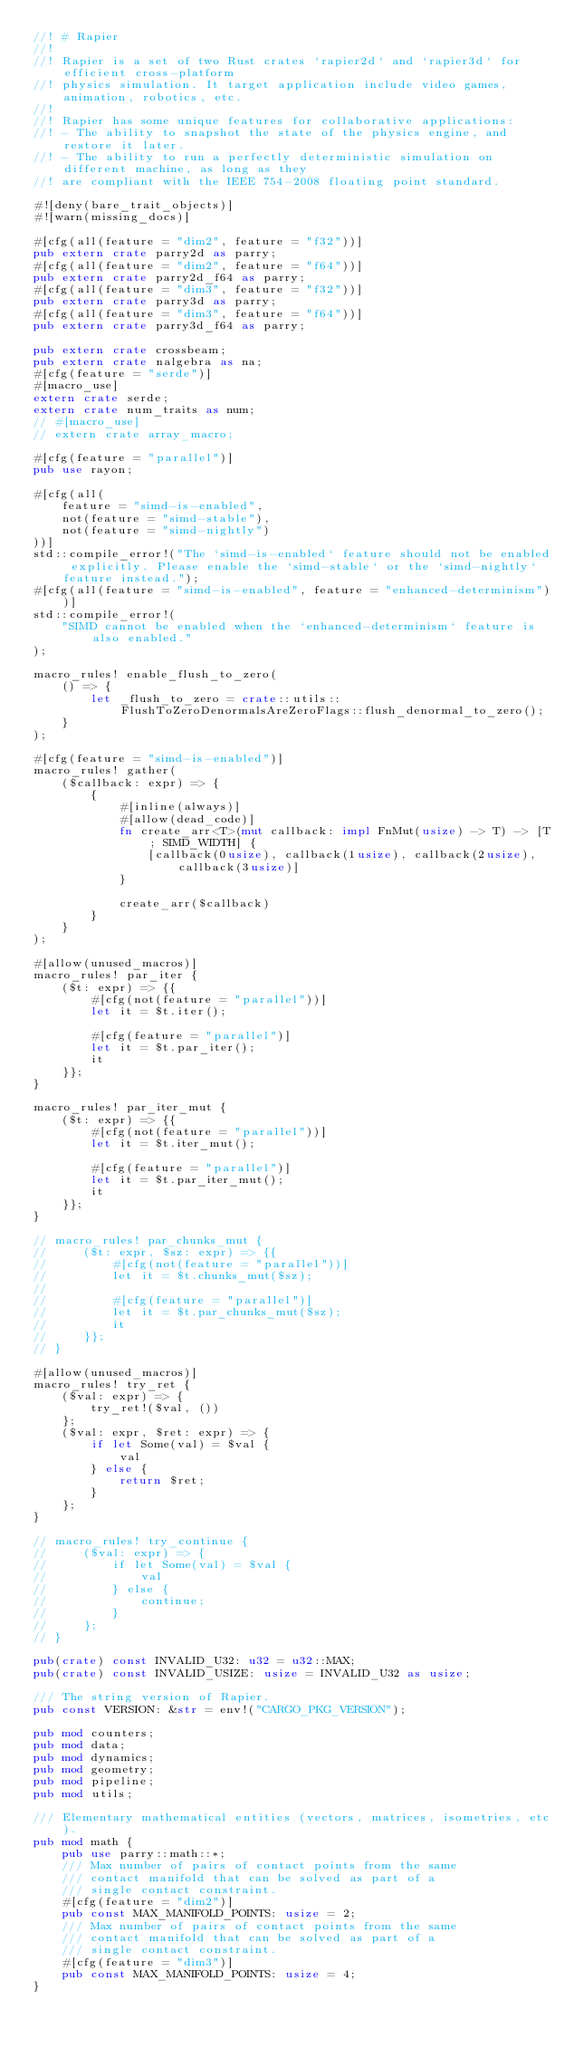<code> <loc_0><loc_0><loc_500><loc_500><_Rust_>//! # Rapier
//!
//! Rapier is a set of two Rust crates `rapier2d` and `rapier3d` for efficient cross-platform
//! physics simulation. It target application include video games, animation, robotics, etc.
//!
//! Rapier has some unique features for collaborative applications:
//! - The ability to snapshot the state of the physics engine, and restore it later.
//! - The ability to run a perfectly deterministic simulation on different machine, as long as they
//! are compliant with the IEEE 754-2008 floating point standard.

#![deny(bare_trait_objects)]
#![warn(missing_docs)]

#[cfg(all(feature = "dim2", feature = "f32"))]
pub extern crate parry2d as parry;
#[cfg(all(feature = "dim2", feature = "f64"))]
pub extern crate parry2d_f64 as parry;
#[cfg(all(feature = "dim3", feature = "f32"))]
pub extern crate parry3d as parry;
#[cfg(all(feature = "dim3", feature = "f64"))]
pub extern crate parry3d_f64 as parry;

pub extern crate crossbeam;
pub extern crate nalgebra as na;
#[cfg(feature = "serde")]
#[macro_use]
extern crate serde;
extern crate num_traits as num;
// #[macro_use]
// extern crate array_macro;

#[cfg(feature = "parallel")]
pub use rayon;

#[cfg(all(
    feature = "simd-is-enabled",
    not(feature = "simd-stable"),
    not(feature = "simd-nightly")
))]
std::compile_error!("The `simd-is-enabled` feature should not be enabled explicitly. Please enable the `simd-stable` or the `simd-nightly` feature instead.");
#[cfg(all(feature = "simd-is-enabled", feature = "enhanced-determinism"))]
std::compile_error!(
    "SIMD cannot be enabled when the `enhanced-determinism` feature is also enabled."
);

macro_rules! enable_flush_to_zero(
    () => {
        let _flush_to_zero = crate::utils::FlushToZeroDenormalsAreZeroFlags::flush_denormal_to_zero();
    }
);

#[cfg(feature = "simd-is-enabled")]
macro_rules! gather(
    ($callback: expr) => {
        {
            #[inline(always)]
            #[allow(dead_code)]
            fn create_arr<T>(mut callback: impl FnMut(usize) -> T) -> [T; SIMD_WIDTH] {
                [callback(0usize), callback(1usize), callback(2usize), callback(3usize)]
            }

            create_arr($callback)
        }
    }
);

#[allow(unused_macros)]
macro_rules! par_iter {
    ($t: expr) => {{
        #[cfg(not(feature = "parallel"))]
        let it = $t.iter();

        #[cfg(feature = "parallel")]
        let it = $t.par_iter();
        it
    }};
}

macro_rules! par_iter_mut {
    ($t: expr) => {{
        #[cfg(not(feature = "parallel"))]
        let it = $t.iter_mut();

        #[cfg(feature = "parallel")]
        let it = $t.par_iter_mut();
        it
    }};
}

// macro_rules! par_chunks_mut {
//     ($t: expr, $sz: expr) => {{
//         #[cfg(not(feature = "parallel"))]
//         let it = $t.chunks_mut($sz);
//
//         #[cfg(feature = "parallel")]
//         let it = $t.par_chunks_mut($sz);
//         it
//     }};
// }

#[allow(unused_macros)]
macro_rules! try_ret {
    ($val: expr) => {
        try_ret!($val, ())
    };
    ($val: expr, $ret: expr) => {
        if let Some(val) = $val {
            val
        } else {
            return $ret;
        }
    };
}

// macro_rules! try_continue {
//     ($val: expr) => {
//         if let Some(val) = $val {
//             val
//         } else {
//             continue;
//         }
//     };
// }

pub(crate) const INVALID_U32: u32 = u32::MAX;
pub(crate) const INVALID_USIZE: usize = INVALID_U32 as usize;

/// The string version of Rapier.
pub const VERSION: &str = env!("CARGO_PKG_VERSION");

pub mod counters;
pub mod data;
pub mod dynamics;
pub mod geometry;
pub mod pipeline;
pub mod utils;

/// Elementary mathematical entities (vectors, matrices, isometries, etc).
pub mod math {
    pub use parry::math::*;
    /// Max number of pairs of contact points from the same
    /// contact manifold that can be solved as part of a
    /// single contact constraint.
    #[cfg(feature = "dim2")]
    pub const MAX_MANIFOLD_POINTS: usize = 2;
    /// Max number of pairs of contact points from the same
    /// contact manifold that can be solved as part of a
    /// single contact constraint.
    #[cfg(feature = "dim3")]
    pub const MAX_MANIFOLD_POINTS: usize = 4;
}
</code> 